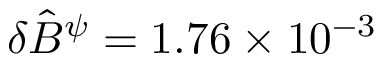<formula> <loc_0><loc_0><loc_500><loc_500>\delta \hat { B } ^ { \psi } = 1 . 7 6 \times 1 0 ^ { - 3 }</formula> 